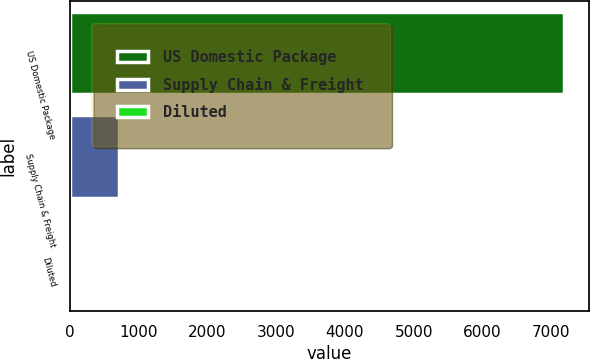Convert chart. <chart><loc_0><loc_0><loc_500><loc_500><bar_chart><fcel>US Domestic Package<fcel>Supply Chain & Freight<fcel>Diluted<nl><fcel>7187<fcel>719.38<fcel>0.76<nl></chart> 